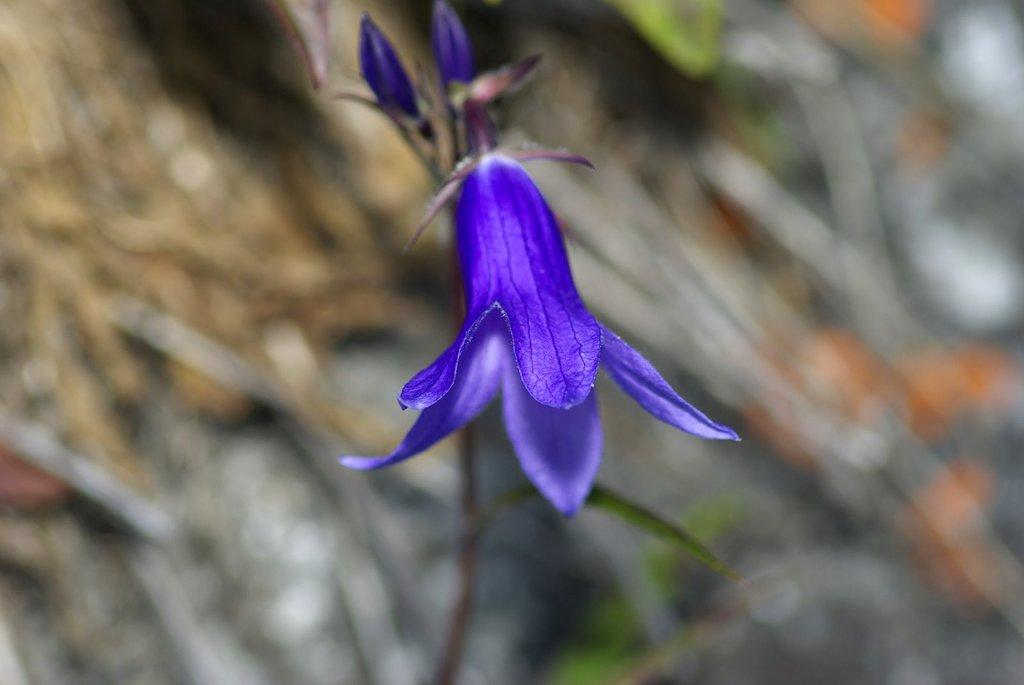What is the main subject of the image? There is a flower in the image. What color is the flower? The flower is violet in color. Can you describe the background of the image? The background of the image is blurred. What flavor of ice cream is being served at the meeting in the image? There is no meeting or ice cream present in the image; it features a violet flower with a blurred background. 